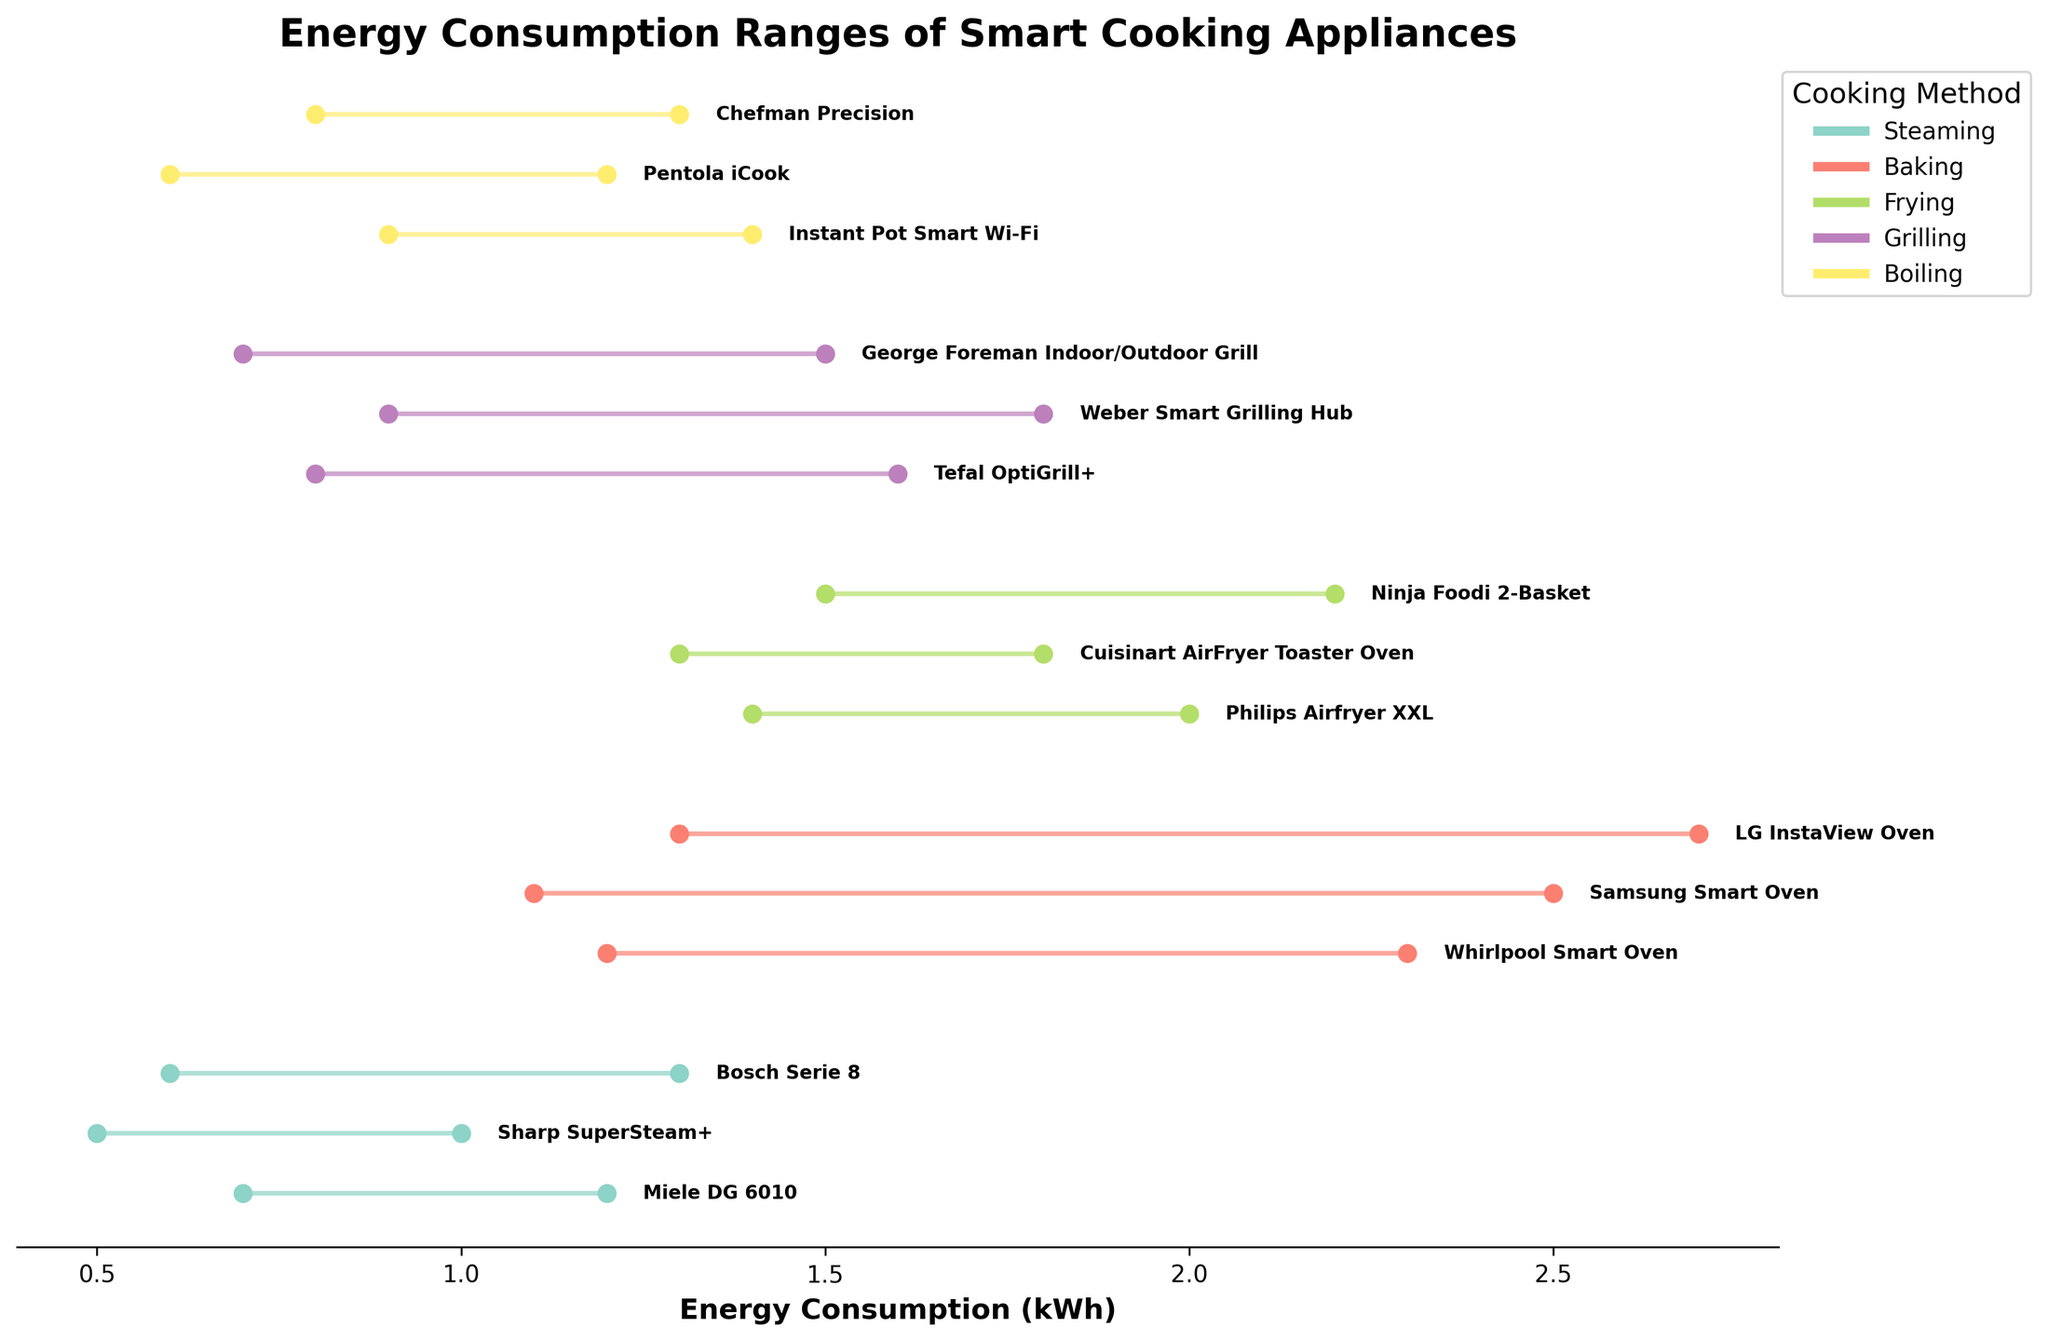How many appliances are listed under the 'Baking' cooking method? Look at the plotted appliances categorized under 'Baking' and count the total number of appliances.
Answer: 3 Which cooking method ranges between the lowest and highest energy consumption limits? Identify the cooking method categorized by the smallest and largest ranges by comparing the energy consumption ranges (minimum to maximum) visually.
Answer: Baking Which appliance has the narrowest energy consumption range? Find the appliance represented by the shortest horizontal line on the plot, as the range represents the energy consumption difference (max-min).
Answer: Sharp SuperSteam+ What's the average maximum energy consumption for all appliances listed under 'Grilling'? Add up the maximum energy consumptions for appliances under 'Grilling' and divide by the number of appliances.
Answer: (1.6 + 1.8 + 1.5)/3 = 1.63 kWh What's the median maximum energy consumption for all 'Steaming' appliances? List all max energy consumptions for 'Steaming' appliances, sort them, and find the middle value.
Answer: 1.2 kWh Which cooking method has the highest variance in energy consumption among its appliances? Calculate the range (max-min) for each appliance and compare the variances (differences). Identify the method with the largest variability.
Answer: Baking Is there an appliance that overlaps in energy consumption ranges with the 'Chefman Precision' boiling appliance? Check if other appliances have energy ranges that intersect with 'Chefman Precision' (0.8 to 1.3 kWh).
Answer: Yes, Instant Pot Smart Wi-Fi and Pentola iCook Which cooking method generally consumes the least energy? Compare the minimum energy consumption values across all listed cooking methods and identify the one with the smallest overall values.
Answer: Steaming 